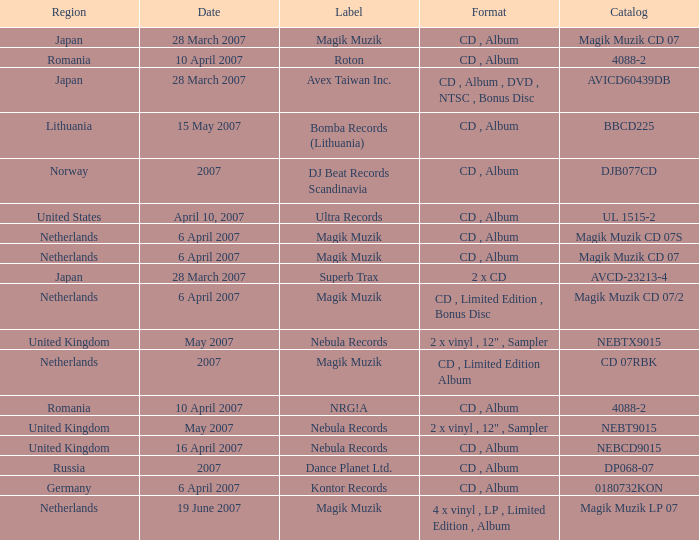Which label released the catalog Magik Muzik CD 07 on 28 March 2007? Magik Muzik. 